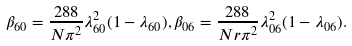Convert formula to latex. <formula><loc_0><loc_0><loc_500><loc_500>\beta _ { 6 0 } = \frac { 2 8 8 } { N \pi ^ { 2 } } \lambda _ { 6 0 } ^ { 2 } ( 1 - \lambda _ { 6 0 } ) , \beta _ { 0 6 } = \frac { 2 8 8 } { N r \pi ^ { 2 } } \lambda _ { 0 6 } ^ { 2 } ( 1 - \lambda _ { 0 6 } ) .</formula> 